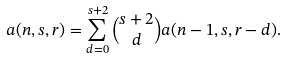<formula> <loc_0><loc_0><loc_500><loc_500>a ( n , s , r ) = \sum _ { d = 0 } ^ { s + 2 } \binom { s + 2 } { d } a ( n - 1 , s , r - d ) .</formula> 